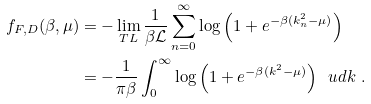Convert formula to latex. <formula><loc_0><loc_0><loc_500><loc_500>f _ { F , D } ( \beta , \mu ) & = - \lim _ { T L } \frac { 1 } { \mathcal { \beta L } } \sum _ { n = 0 } ^ { \infty } \log { \left ( 1 + e ^ { - \beta ( k ^ { 2 } _ { n } - \mu ) } \right ) } \\ & = - \frac { 1 } { \pi \beta } \int _ { 0 } ^ { \infty } \log { \left ( 1 + e ^ { - \beta ( k ^ { 2 } - \mu ) } \right ) } \ \ u d k \ .</formula> 